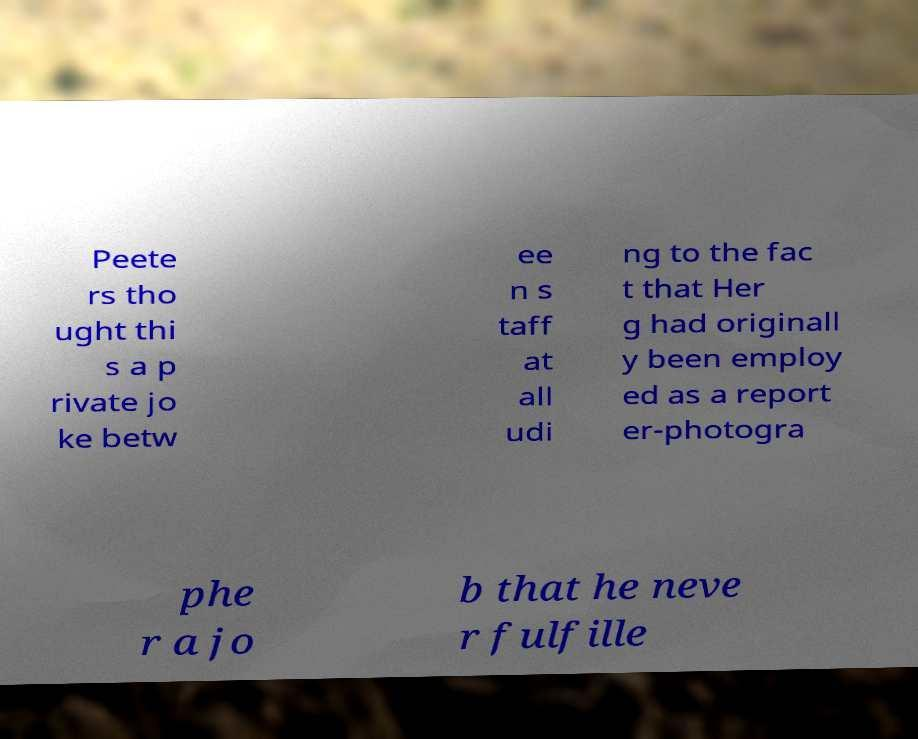Could you assist in decoding the text presented in this image and type it out clearly? Peete rs tho ught thi s a p rivate jo ke betw ee n s taff at all udi ng to the fac t that Her g had originall y been employ ed as a report er-photogra phe r a jo b that he neve r fulfille 